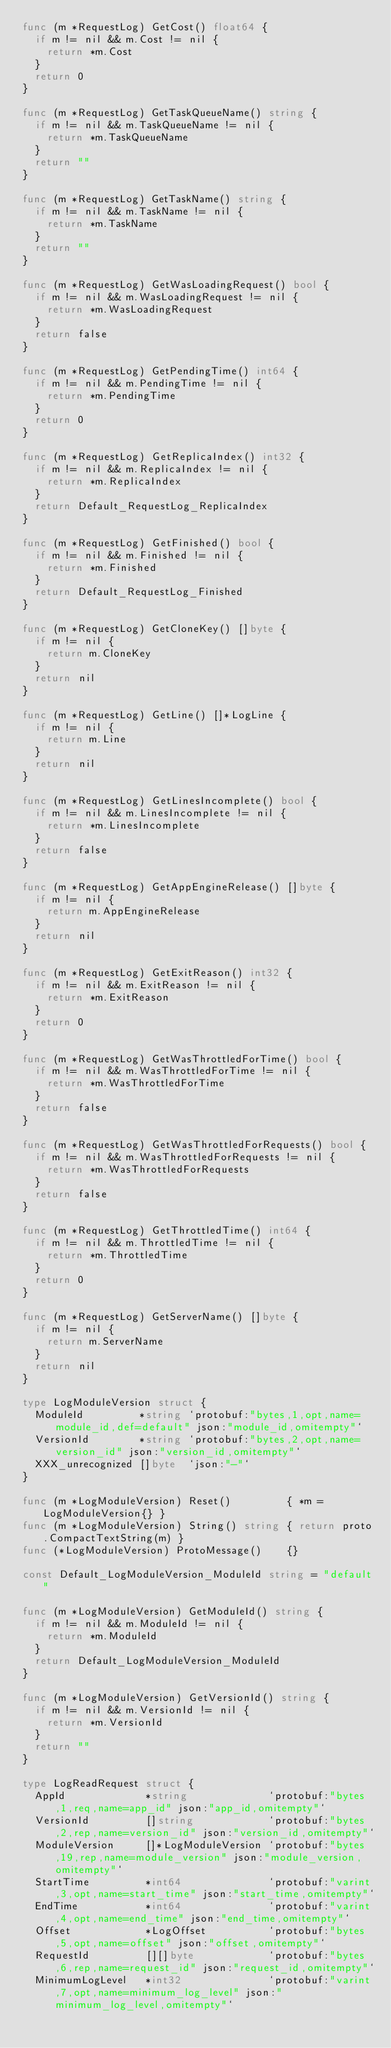Convert code to text. <code><loc_0><loc_0><loc_500><loc_500><_Go_>func (m *RequestLog) GetCost() float64 {
	if m != nil && m.Cost != nil {
		return *m.Cost
	}
	return 0
}

func (m *RequestLog) GetTaskQueueName() string {
	if m != nil && m.TaskQueueName != nil {
		return *m.TaskQueueName
	}
	return ""
}

func (m *RequestLog) GetTaskName() string {
	if m != nil && m.TaskName != nil {
		return *m.TaskName
	}
	return ""
}

func (m *RequestLog) GetWasLoadingRequest() bool {
	if m != nil && m.WasLoadingRequest != nil {
		return *m.WasLoadingRequest
	}
	return false
}

func (m *RequestLog) GetPendingTime() int64 {
	if m != nil && m.PendingTime != nil {
		return *m.PendingTime
	}
	return 0
}

func (m *RequestLog) GetReplicaIndex() int32 {
	if m != nil && m.ReplicaIndex != nil {
		return *m.ReplicaIndex
	}
	return Default_RequestLog_ReplicaIndex
}

func (m *RequestLog) GetFinished() bool {
	if m != nil && m.Finished != nil {
		return *m.Finished
	}
	return Default_RequestLog_Finished
}

func (m *RequestLog) GetCloneKey() []byte {
	if m != nil {
		return m.CloneKey
	}
	return nil
}

func (m *RequestLog) GetLine() []*LogLine {
	if m != nil {
		return m.Line
	}
	return nil
}

func (m *RequestLog) GetLinesIncomplete() bool {
	if m != nil && m.LinesIncomplete != nil {
		return *m.LinesIncomplete
	}
	return false
}

func (m *RequestLog) GetAppEngineRelease() []byte {
	if m != nil {
		return m.AppEngineRelease
	}
	return nil
}

func (m *RequestLog) GetExitReason() int32 {
	if m != nil && m.ExitReason != nil {
		return *m.ExitReason
	}
	return 0
}

func (m *RequestLog) GetWasThrottledForTime() bool {
	if m != nil && m.WasThrottledForTime != nil {
		return *m.WasThrottledForTime
	}
	return false
}

func (m *RequestLog) GetWasThrottledForRequests() bool {
	if m != nil && m.WasThrottledForRequests != nil {
		return *m.WasThrottledForRequests
	}
	return false
}

func (m *RequestLog) GetThrottledTime() int64 {
	if m != nil && m.ThrottledTime != nil {
		return *m.ThrottledTime
	}
	return 0
}

func (m *RequestLog) GetServerName() []byte {
	if m != nil {
		return m.ServerName
	}
	return nil
}

type LogModuleVersion struct {
	ModuleId         *string `protobuf:"bytes,1,opt,name=module_id,def=default" json:"module_id,omitempty"`
	VersionId        *string `protobuf:"bytes,2,opt,name=version_id" json:"version_id,omitempty"`
	XXX_unrecognized []byte  `json:"-"`
}

func (m *LogModuleVersion) Reset()         { *m = LogModuleVersion{} }
func (m *LogModuleVersion) String() string { return proto.CompactTextString(m) }
func (*LogModuleVersion) ProtoMessage()    {}

const Default_LogModuleVersion_ModuleId string = "default"

func (m *LogModuleVersion) GetModuleId() string {
	if m != nil && m.ModuleId != nil {
		return *m.ModuleId
	}
	return Default_LogModuleVersion_ModuleId
}

func (m *LogModuleVersion) GetVersionId() string {
	if m != nil && m.VersionId != nil {
		return *m.VersionId
	}
	return ""
}

type LogReadRequest struct {
	AppId             *string             `protobuf:"bytes,1,req,name=app_id" json:"app_id,omitempty"`
	VersionId         []string            `protobuf:"bytes,2,rep,name=version_id" json:"version_id,omitempty"`
	ModuleVersion     []*LogModuleVersion `protobuf:"bytes,19,rep,name=module_version" json:"module_version,omitempty"`
	StartTime         *int64              `protobuf:"varint,3,opt,name=start_time" json:"start_time,omitempty"`
	EndTime           *int64              `protobuf:"varint,4,opt,name=end_time" json:"end_time,omitempty"`
	Offset            *LogOffset          `protobuf:"bytes,5,opt,name=offset" json:"offset,omitempty"`
	RequestId         [][]byte            `protobuf:"bytes,6,rep,name=request_id" json:"request_id,omitempty"`
	MinimumLogLevel   *int32              `protobuf:"varint,7,opt,name=minimum_log_level" json:"minimum_log_level,omitempty"`</code> 